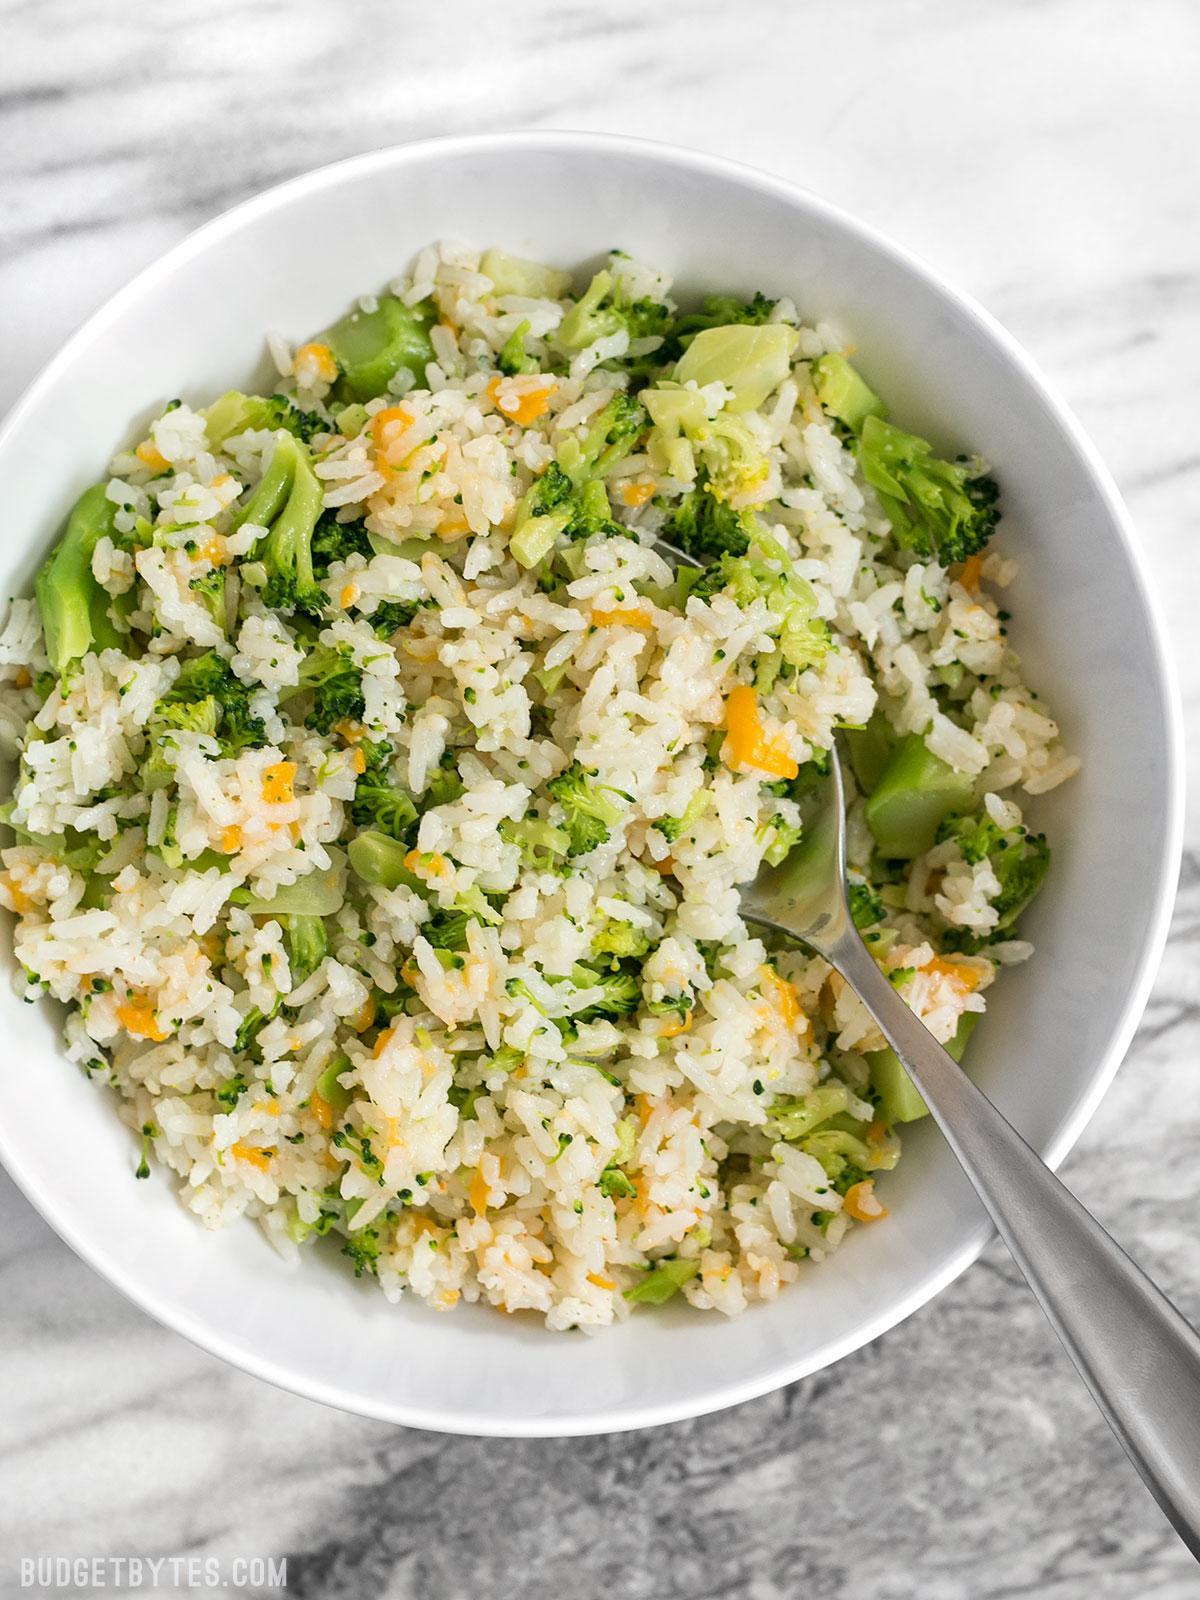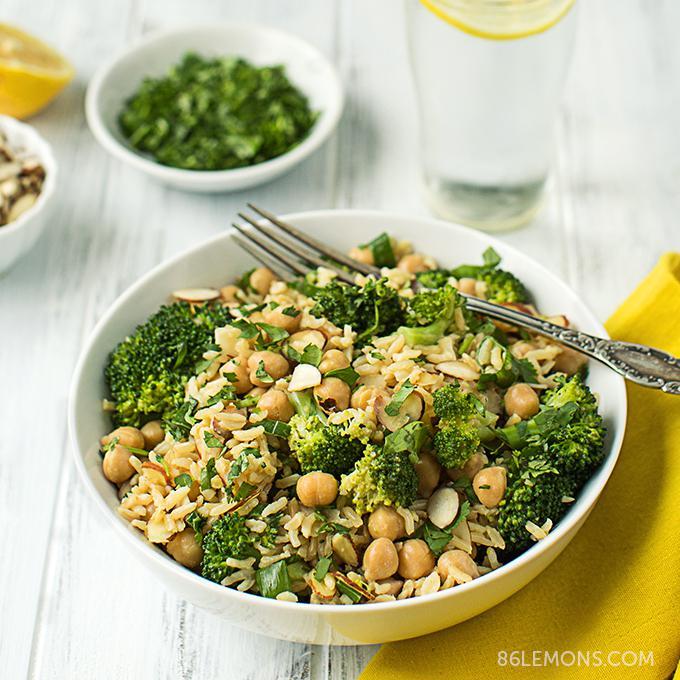The first image is the image on the left, the second image is the image on the right. Evaluate the accuracy of this statement regarding the images: "There is at least one fork clearly visible.". Is it true? Answer yes or no. Yes. 